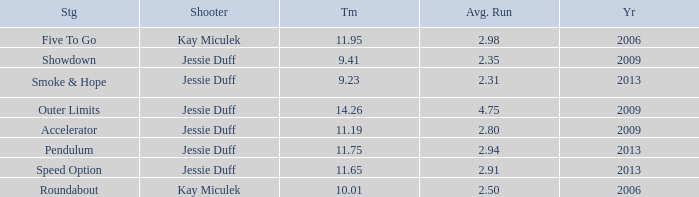What is the total amount of time for years prior to 2013 when speed option is the stage? None. 